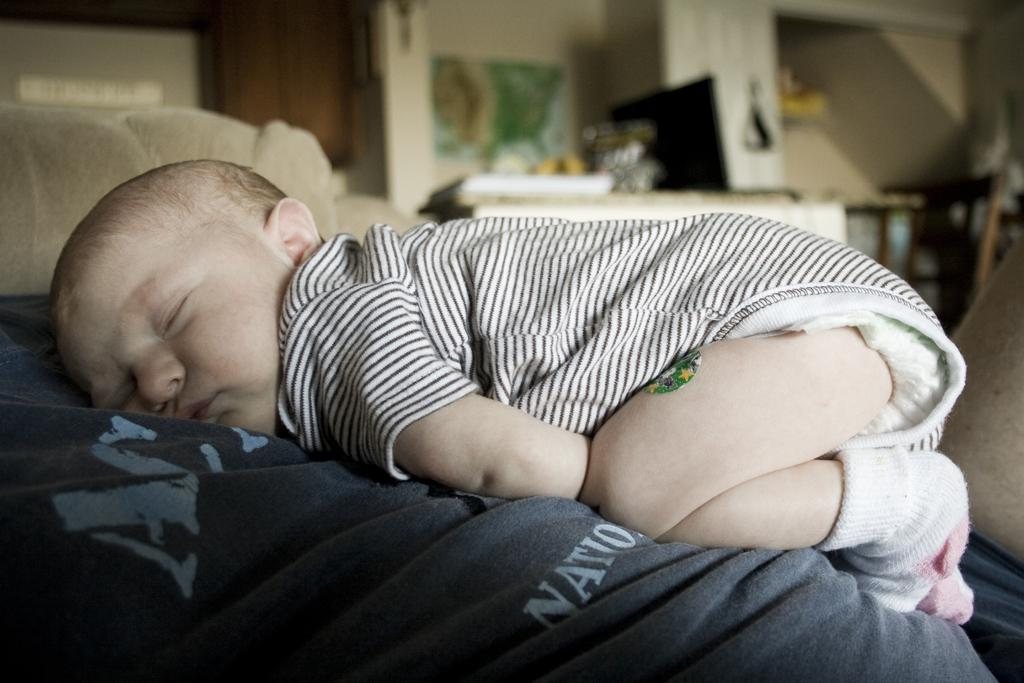What is the main subject of the image? There is a baby in the image. What is the baby doing in the image? The baby is sleeping on a bed. What can be seen in the background of the image? There is a table and a wall in the background of the image. What type of advertisement can be seen on the wall in the image? There is no advertisement present on the wall in the image. What is the baby using to plough the field in the image? The baby is sleeping on a bed and there is no plough or field present in the image. 